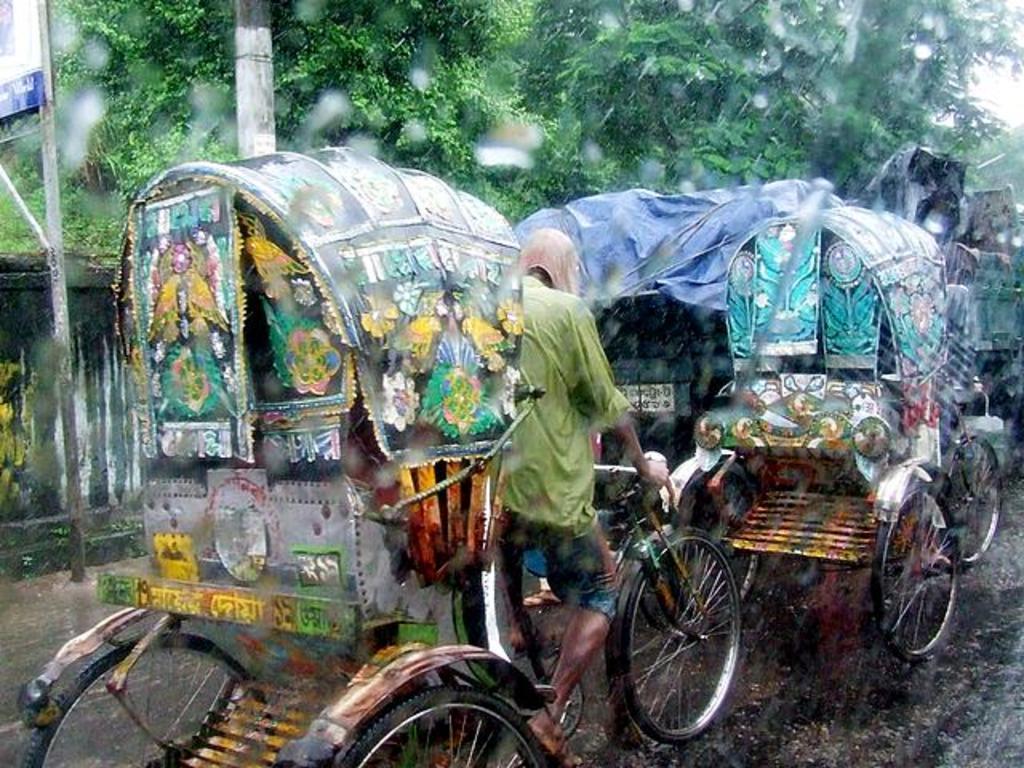Can you describe this image briefly? In this image there are rashes on a road, in the background there are trees and it is raining. 